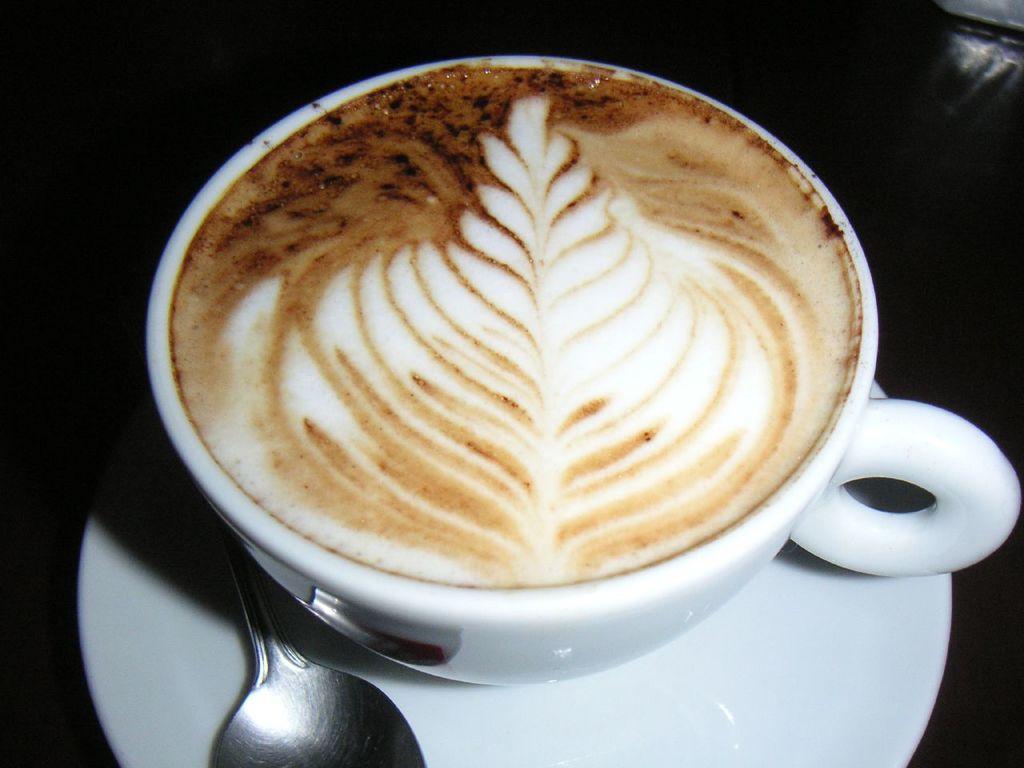Can you describe this image briefly? Here we can see a coffee cup, saucer, and a spoon. There is a dark background. 